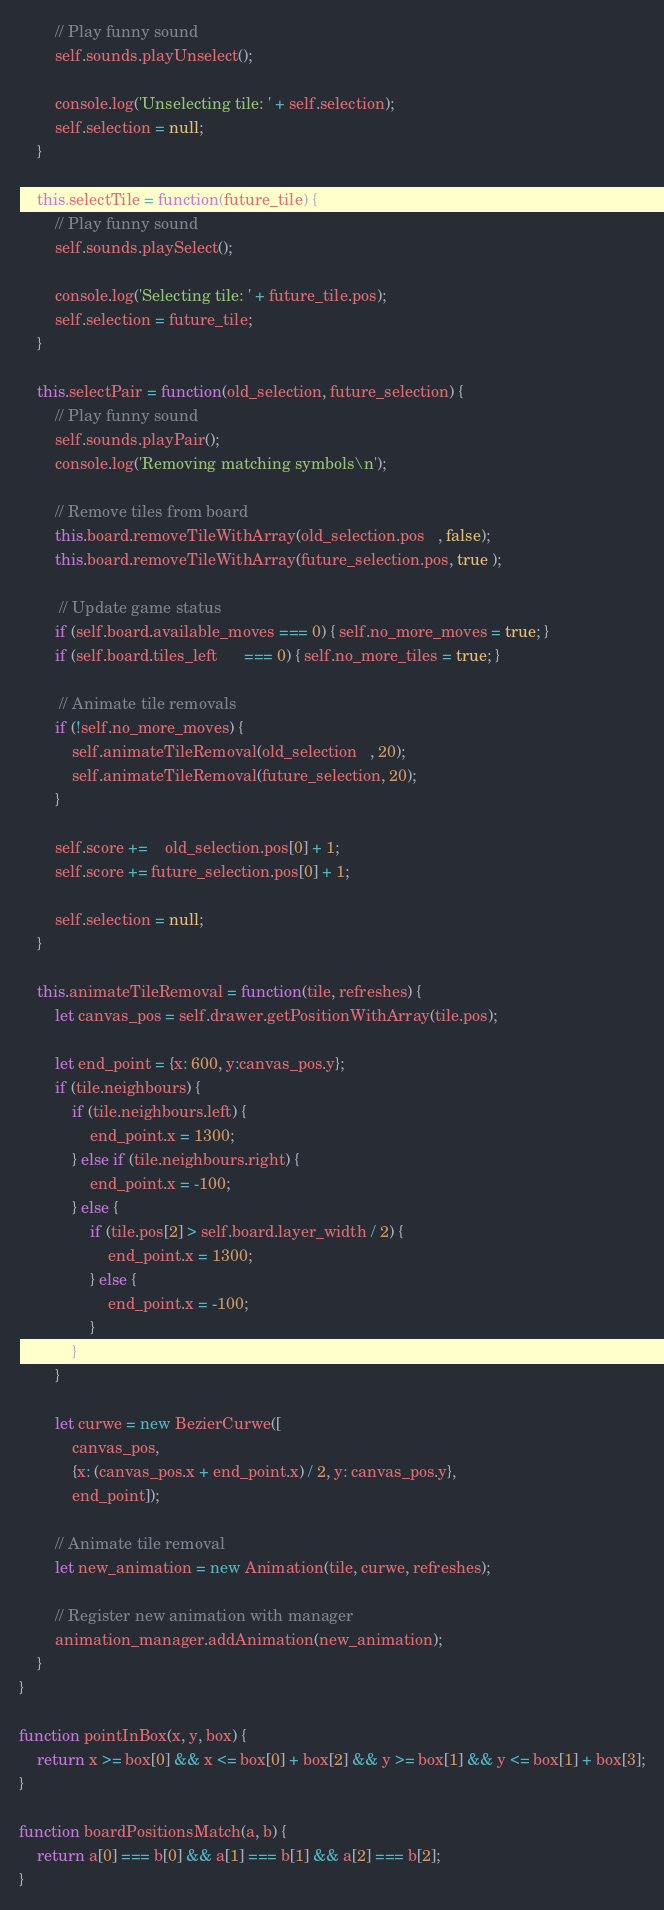Convert code to text. <code><loc_0><loc_0><loc_500><loc_500><_JavaScript_>        // Play funny sound
        self.sounds.playUnselect();

        console.log('Unselecting tile: ' + self.selection);
        self.selection = null;
    }

    this.selectTile = function(future_tile) {
        // Play funny sound
        self.sounds.playSelect();

        console.log('Selecting tile: ' + future_tile.pos);
        self.selection = future_tile; 
    }

    this.selectPair = function(old_selection, future_selection) {
        // Play funny sound
        self.sounds.playPair();
        console.log('Removing matching symbols\n'); 

        // Remove tiles from board
        this.board.removeTileWithArray(old_selection.pos   , false);
        this.board.removeTileWithArray(future_selection.pos, true );

         // Update game status
        if (self.board.available_moves === 0) { self.no_more_moves = true; }
        if (self.board.tiles_left      === 0) { self.no_more_tiles = true; }  

         // Animate tile removals
        if (!self.no_more_moves) {
            self.animateTileRemoval(old_selection   , 20);
            self.animateTileRemoval(future_selection, 20);
        }

        self.score +=    old_selection.pos[0] + 1;
        self.score += future_selection.pos[0] + 1;

        self.selection = null;
    }

    this.animateTileRemoval = function(tile, refreshes) {
        let canvas_pos = self.drawer.getPositionWithArray(tile.pos);
        
        let end_point = {x: 600, y:canvas_pos.y};
        if (tile.neighbours) {
            if (tile.neighbours.left) {
                end_point.x = 1300;
            } else if (tile.neighbours.right) {
                end_point.x = -100;
            } else {
                if (tile.pos[2] > self.board.layer_width / 2) {
                    end_point.x = 1300;
                } else {
                    end_point.x = -100;
                }
            }
        }

        let curwe = new BezierCurwe([
            canvas_pos, 
            {x: (canvas_pos.x + end_point.x) / 2, y: canvas_pos.y},
            end_point]);
        
        // Animate tile removal
        let new_animation = new Animation(tile, curwe, refreshes);

        // Register new animation with manager
        animation_manager.addAnimation(new_animation);
    }
}

function pointInBox(x, y, box) {
    return x >= box[0] && x <= box[0] + box[2] && y >= box[1] && y <= box[1] + box[3];
}

function boardPositionsMatch(a, b) {
    return a[0] === b[0] && a[1] === b[1] && a[2] === b[2];
}</code> 